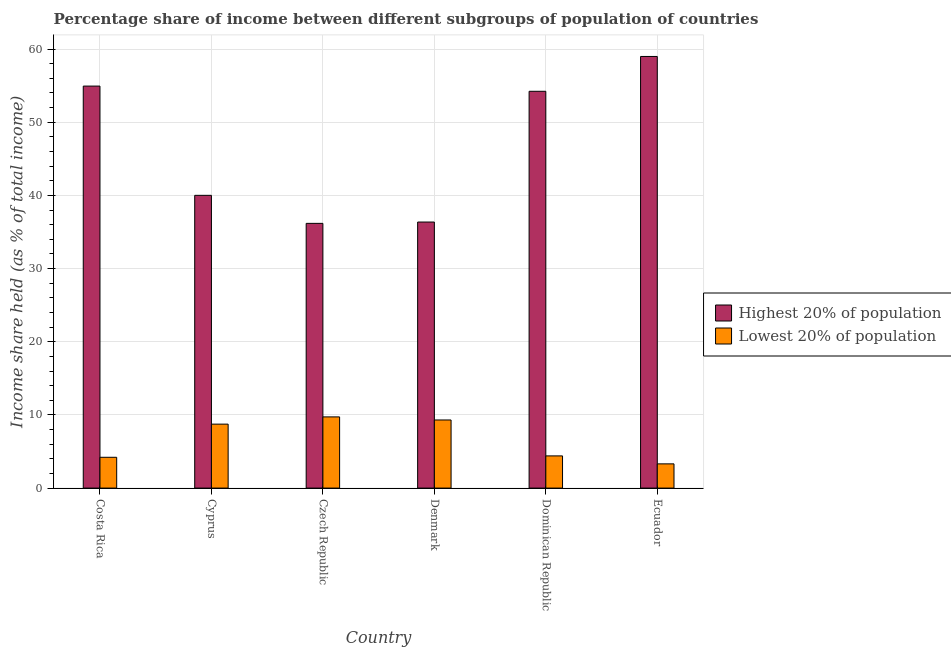How many different coloured bars are there?
Offer a very short reply. 2. How many groups of bars are there?
Your answer should be very brief. 6. Are the number of bars per tick equal to the number of legend labels?
Make the answer very short. Yes. How many bars are there on the 6th tick from the right?
Provide a succinct answer. 2. What is the income share held by highest 20% of the population in Denmark?
Your answer should be very brief. 36.36. Across all countries, what is the maximum income share held by highest 20% of the population?
Your answer should be compact. 58.99. Across all countries, what is the minimum income share held by lowest 20% of the population?
Provide a short and direct response. 3.31. In which country was the income share held by lowest 20% of the population maximum?
Your response must be concise. Czech Republic. In which country was the income share held by highest 20% of the population minimum?
Ensure brevity in your answer.  Czech Republic. What is the total income share held by highest 20% of the population in the graph?
Keep it short and to the point. 280.71. What is the difference between the income share held by lowest 20% of the population in Costa Rica and that in Czech Republic?
Make the answer very short. -5.52. What is the difference between the income share held by highest 20% of the population in Costa Rica and the income share held by lowest 20% of the population in Czech Republic?
Your response must be concise. 45.21. What is the average income share held by lowest 20% of the population per country?
Provide a succinct answer. 6.62. What is the difference between the income share held by highest 20% of the population and income share held by lowest 20% of the population in Costa Rica?
Make the answer very short. 50.73. What is the ratio of the income share held by lowest 20% of the population in Czech Republic to that in Ecuador?
Your response must be concise. 2.94. Is the difference between the income share held by lowest 20% of the population in Costa Rica and Ecuador greater than the difference between the income share held by highest 20% of the population in Costa Rica and Ecuador?
Make the answer very short. Yes. What is the difference between the highest and the second highest income share held by lowest 20% of the population?
Your response must be concise. 0.42. What is the difference between the highest and the lowest income share held by highest 20% of the population?
Make the answer very short. 22.81. In how many countries, is the income share held by lowest 20% of the population greater than the average income share held by lowest 20% of the population taken over all countries?
Provide a short and direct response. 3. Is the sum of the income share held by highest 20% of the population in Costa Rica and Denmark greater than the maximum income share held by lowest 20% of the population across all countries?
Provide a succinct answer. Yes. What does the 2nd bar from the left in Costa Rica represents?
Make the answer very short. Lowest 20% of population. What does the 1st bar from the right in Costa Rica represents?
Ensure brevity in your answer.  Lowest 20% of population. How many bars are there?
Your answer should be compact. 12. Are all the bars in the graph horizontal?
Offer a terse response. No. How many countries are there in the graph?
Provide a short and direct response. 6. What is the difference between two consecutive major ticks on the Y-axis?
Offer a terse response. 10. Does the graph contain grids?
Provide a succinct answer. Yes. What is the title of the graph?
Your answer should be compact. Percentage share of income between different subgroups of population of countries. What is the label or title of the X-axis?
Offer a terse response. Country. What is the label or title of the Y-axis?
Your answer should be very brief. Income share held (as % of total income). What is the Income share held (as % of total income) in Highest 20% of population in Costa Rica?
Ensure brevity in your answer.  54.94. What is the Income share held (as % of total income) of Lowest 20% of population in Costa Rica?
Your answer should be compact. 4.21. What is the Income share held (as % of total income) of Highest 20% of population in Cyprus?
Keep it short and to the point. 40.01. What is the Income share held (as % of total income) in Lowest 20% of population in Cyprus?
Your answer should be compact. 8.74. What is the Income share held (as % of total income) of Highest 20% of population in Czech Republic?
Offer a terse response. 36.18. What is the Income share held (as % of total income) in Lowest 20% of population in Czech Republic?
Provide a succinct answer. 9.73. What is the Income share held (as % of total income) of Highest 20% of population in Denmark?
Offer a very short reply. 36.36. What is the Income share held (as % of total income) in Lowest 20% of population in Denmark?
Your answer should be very brief. 9.31. What is the Income share held (as % of total income) in Highest 20% of population in Dominican Republic?
Offer a terse response. 54.23. What is the Income share held (as % of total income) in Highest 20% of population in Ecuador?
Ensure brevity in your answer.  58.99. What is the Income share held (as % of total income) of Lowest 20% of population in Ecuador?
Your response must be concise. 3.31. Across all countries, what is the maximum Income share held (as % of total income) in Highest 20% of population?
Your answer should be compact. 58.99. Across all countries, what is the maximum Income share held (as % of total income) of Lowest 20% of population?
Your response must be concise. 9.73. Across all countries, what is the minimum Income share held (as % of total income) of Highest 20% of population?
Give a very brief answer. 36.18. Across all countries, what is the minimum Income share held (as % of total income) in Lowest 20% of population?
Offer a very short reply. 3.31. What is the total Income share held (as % of total income) in Highest 20% of population in the graph?
Provide a short and direct response. 280.71. What is the total Income share held (as % of total income) of Lowest 20% of population in the graph?
Your answer should be very brief. 39.7. What is the difference between the Income share held (as % of total income) in Highest 20% of population in Costa Rica and that in Cyprus?
Offer a very short reply. 14.93. What is the difference between the Income share held (as % of total income) in Lowest 20% of population in Costa Rica and that in Cyprus?
Ensure brevity in your answer.  -4.53. What is the difference between the Income share held (as % of total income) in Highest 20% of population in Costa Rica and that in Czech Republic?
Offer a terse response. 18.76. What is the difference between the Income share held (as % of total income) in Lowest 20% of population in Costa Rica and that in Czech Republic?
Provide a succinct answer. -5.52. What is the difference between the Income share held (as % of total income) in Highest 20% of population in Costa Rica and that in Denmark?
Provide a short and direct response. 18.58. What is the difference between the Income share held (as % of total income) of Lowest 20% of population in Costa Rica and that in Denmark?
Provide a succinct answer. -5.1. What is the difference between the Income share held (as % of total income) in Highest 20% of population in Costa Rica and that in Dominican Republic?
Your answer should be compact. 0.71. What is the difference between the Income share held (as % of total income) of Lowest 20% of population in Costa Rica and that in Dominican Republic?
Ensure brevity in your answer.  -0.19. What is the difference between the Income share held (as % of total income) of Highest 20% of population in Costa Rica and that in Ecuador?
Ensure brevity in your answer.  -4.05. What is the difference between the Income share held (as % of total income) in Lowest 20% of population in Costa Rica and that in Ecuador?
Your response must be concise. 0.9. What is the difference between the Income share held (as % of total income) of Highest 20% of population in Cyprus and that in Czech Republic?
Make the answer very short. 3.83. What is the difference between the Income share held (as % of total income) of Lowest 20% of population in Cyprus and that in Czech Republic?
Your answer should be very brief. -0.99. What is the difference between the Income share held (as % of total income) in Highest 20% of population in Cyprus and that in Denmark?
Your answer should be very brief. 3.65. What is the difference between the Income share held (as % of total income) in Lowest 20% of population in Cyprus and that in Denmark?
Give a very brief answer. -0.57. What is the difference between the Income share held (as % of total income) in Highest 20% of population in Cyprus and that in Dominican Republic?
Give a very brief answer. -14.22. What is the difference between the Income share held (as % of total income) in Lowest 20% of population in Cyprus and that in Dominican Republic?
Offer a terse response. 4.34. What is the difference between the Income share held (as % of total income) in Highest 20% of population in Cyprus and that in Ecuador?
Offer a terse response. -18.98. What is the difference between the Income share held (as % of total income) of Lowest 20% of population in Cyprus and that in Ecuador?
Ensure brevity in your answer.  5.43. What is the difference between the Income share held (as % of total income) of Highest 20% of population in Czech Republic and that in Denmark?
Offer a terse response. -0.18. What is the difference between the Income share held (as % of total income) in Lowest 20% of population in Czech Republic and that in Denmark?
Give a very brief answer. 0.42. What is the difference between the Income share held (as % of total income) of Highest 20% of population in Czech Republic and that in Dominican Republic?
Offer a terse response. -18.05. What is the difference between the Income share held (as % of total income) of Lowest 20% of population in Czech Republic and that in Dominican Republic?
Provide a short and direct response. 5.33. What is the difference between the Income share held (as % of total income) in Highest 20% of population in Czech Republic and that in Ecuador?
Make the answer very short. -22.81. What is the difference between the Income share held (as % of total income) in Lowest 20% of population in Czech Republic and that in Ecuador?
Your answer should be compact. 6.42. What is the difference between the Income share held (as % of total income) in Highest 20% of population in Denmark and that in Dominican Republic?
Your answer should be compact. -17.87. What is the difference between the Income share held (as % of total income) of Lowest 20% of population in Denmark and that in Dominican Republic?
Your answer should be compact. 4.91. What is the difference between the Income share held (as % of total income) of Highest 20% of population in Denmark and that in Ecuador?
Provide a succinct answer. -22.63. What is the difference between the Income share held (as % of total income) in Lowest 20% of population in Denmark and that in Ecuador?
Provide a succinct answer. 6. What is the difference between the Income share held (as % of total income) of Highest 20% of population in Dominican Republic and that in Ecuador?
Your answer should be compact. -4.76. What is the difference between the Income share held (as % of total income) in Lowest 20% of population in Dominican Republic and that in Ecuador?
Your answer should be very brief. 1.09. What is the difference between the Income share held (as % of total income) of Highest 20% of population in Costa Rica and the Income share held (as % of total income) of Lowest 20% of population in Cyprus?
Ensure brevity in your answer.  46.2. What is the difference between the Income share held (as % of total income) of Highest 20% of population in Costa Rica and the Income share held (as % of total income) of Lowest 20% of population in Czech Republic?
Your answer should be very brief. 45.21. What is the difference between the Income share held (as % of total income) in Highest 20% of population in Costa Rica and the Income share held (as % of total income) in Lowest 20% of population in Denmark?
Offer a very short reply. 45.63. What is the difference between the Income share held (as % of total income) of Highest 20% of population in Costa Rica and the Income share held (as % of total income) of Lowest 20% of population in Dominican Republic?
Provide a succinct answer. 50.54. What is the difference between the Income share held (as % of total income) in Highest 20% of population in Costa Rica and the Income share held (as % of total income) in Lowest 20% of population in Ecuador?
Make the answer very short. 51.63. What is the difference between the Income share held (as % of total income) of Highest 20% of population in Cyprus and the Income share held (as % of total income) of Lowest 20% of population in Czech Republic?
Make the answer very short. 30.28. What is the difference between the Income share held (as % of total income) of Highest 20% of population in Cyprus and the Income share held (as % of total income) of Lowest 20% of population in Denmark?
Give a very brief answer. 30.7. What is the difference between the Income share held (as % of total income) of Highest 20% of population in Cyprus and the Income share held (as % of total income) of Lowest 20% of population in Dominican Republic?
Ensure brevity in your answer.  35.61. What is the difference between the Income share held (as % of total income) in Highest 20% of population in Cyprus and the Income share held (as % of total income) in Lowest 20% of population in Ecuador?
Provide a short and direct response. 36.7. What is the difference between the Income share held (as % of total income) in Highest 20% of population in Czech Republic and the Income share held (as % of total income) in Lowest 20% of population in Denmark?
Offer a very short reply. 26.87. What is the difference between the Income share held (as % of total income) in Highest 20% of population in Czech Republic and the Income share held (as % of total income) in Lowest 20% of population in Dominican Republic?
Your answer should be very brief. 31.78. What is the difference between the Income share held (as % of total income) in Highest 20% of population in Czech Republic and the Income share held (as % of total income) in Lowest 20% of population in Ecuador?
Ensure brevity in your answer.  32.87. What is the difference between the Income share held (as % of total income) in Highest 20% of population in Denmark and the Income share held (as % of total income) in Lowest 20% of population in Dominican Republic?
Give a very brief answer. 31.96. What is the difference between the Income share held (as % of total income) in Highest 20% of population in Denmark and the Income share held (as % of total income) in Lowest 20% of population in Ecuador?
Offer a terse response. 33.05. What is the difference between the Income share held (as % of total income) in Highest 20% of population in Dominican Republic and the Income share held (as % of total income) in Lowest 20% of population in Ecuador?
Your answer should be compact. 50.92. What is the average Income share held (as % of total income) in Highest 20% of population per country?
Give a very brief answer. 46.78. What is the average Income share held (as % of total income) of Lowest 20% of population per country?
Ensure brevity in your answer.  6.62. What is the difference between the Income share held (as % of total income) in Highest 20% of population and Income share held (as % of total income) in Lowest 20% of population in Costa Rica?
Your response must be concise. 50.73. What is the difference between the Income share held (as % of total income) of Highest 20% of population and Income share held (as % of total income) of Lowest 20% of population in Cyprus?
Keep it short and to the point. 31.27. What is the difference between the Income share held (as % of total income) of Highest 20% of population and Income share held (as % of total income) of Lowest 20% of population in Czech Republic?
Your response must be concise. 26.45. What is the difference between the Income share held (as % of total income) in Highest 20% of population and Income share held (as % of total income) in Lowest 20% of population in Denmark?
Offer a terse response. 27.05. What is the difference between the Income share held (as % of total income) of Highest 20% of population and Income share held (as % of total income) of Lowest 20% of population in Dominican Republic?
Your answer should be compact. 49.83. What is the difference between the Income share held (as % of total income) of Highest 20% of population and Income share held (as % of total income) of Lowest 20% of population in Ecuador?
Your answer should be very brief. 55.68. What is the ratio of the Income share held (as % of total income) in Highest 20% of population in Costa Rica to that in Cyprus?
Make the answer very short. 1.37. What is the ratio of the Income share held (as % of total income) of Lowest 20% of population in Costa Rica to that in Cyprus?
Your response must be concise. 0.48. What is the ratio of the Income share held (as % of total income) of Highest 20% of population in Costa Rica to that in Czech Republic?
Your answer should be compact. 1.52. What is the ratio of the Income share held (as % of total income) of Lowest 20% of population in Costa Rica to that in Czech Republic?
Your response must be concise. 0.43. What is the ratio of the Income share held (as % of total income) of Highest 20% of population in Costa Rica to that in Denmark?
Your answer should be compact. 1.51. What is the ratio of the Income share held (as % of total income) of Lowest 20% of population in Costa Rica to that in Denmark?
Your response must be concise. 0.45. What is the ratio of the Income share held (as % of total income) in Highest 20% of population in Costa Rica to that in Dominican Republic?
Your response must be concise. 1.01. What is the ratio of the Income share held (as % of total income) of Lowest 20% of population in Costa Rica to that in Dominican Republic?
Offer a very short reply. 0.96. What is the ratio of the Income share held (as % of total income) of Highest 20% of population in Costa Rica to that in Ecuador?
Offer a very short reply. 0.93. What is the ratio of the Income share held (as % of total income) of Lowest 20% of population in Costa Rica to that in Ecuador?
Your answer should be compact. 1.27. What is the ratio of the Income share held (as % of total income) of Highest 20% of population in Cyprus to that in Czech Republic?
Provide a short and direct response. 1.11. What is the ratio of the Income share held (as % of total income) of Lowest 20% of population in Cyprus to that in Czech Republic?
Your response must be concise. 0.9. What is the ratio of the Income share held (as % of total income) of Highest 20% of population in Cyprus to that in Denmark?
Your response must be concise. 1.1. What is the ratio of the Income share held (as % of total income) in Lowest 20% of population in Cyprus to that in Denmark?
Offer a terse response. 0.94. What is the ratio of the Income share held (as % of total income) in Highest 20% of population in Cyprus to that in Dominican Republic?
Provide a succinct answer. 0.74. What is the ratio of the Income share held (as % of total income) in Lowest 20% of population in Cyprus to that in Dominican Republic?
Provide a succinct answer. 1.99. What is the ratio of the Income share held (as % of total income) in Highest 20% of population in Cyprus to that in Ecuador?
Your answer should be compact. 0.68. What is the ratio of the Income share held (as % of total income) in Lowest 20% of population in Cyprus to that in Ecuador?
Your answer should be very brief. 2.64. What is the ratio of the Income share held (as % of total income) in Lowest 20% of population in Czech Republic to that in Denmark?
Keep it short and to the point. 1.05. What is the ratio of the Income share held (as % of total income) in Highest 20% of population in Czech Republic to that in Dominican Republic?
Ensure brevity in your answer.  0.67. What is the ratio of the Income share held (as % of total income) in Lowest 20% of population in Czech Republic to that in Dominican Republic?
Keep it short and to the point. 2.21. What is the ratio of the Income share held (as % of total income) of Highest 20% of population in Czech Republic to that in Ecuador?
Your response must be concise. 0.61. What is the ratio of the Income share held (as % of total income) in Lowest 20% of population in Czech Republic to that in Ecuador?
Your response must be concise. 2.94. What is the ratio of the Income share held (as % of total income) of Highest 20% of population in Denmark to that in Dominican Republic?
Your answer should be very brief. 0.67. What is the ratio of the Income share held (as % of total income) in Lowest 20% of population in Denmark to that in Dominican Republic?
Provide a succinct answer. 2.12. What is the ratio of the Income share held (as % of total income) of Highest 20% of population in Denmark to that in Ecuador?
Your answer should be very brief. 0.62. What is the ratio of the Income share held (as % of total income) in Lowest 20% of population in Denmark to that in Ecuador?
Your answer should be compact. 2.81. What is the ratio of the Income share held (as % of total income) in Highest 20% of population in Dominican Republic to that in Ecuador?
Offer a terse response. 0.92. What is the ratio of the Income share held (as % of total income) of Lowest 20% of population in Dominican Republic to that in Ecuador?
Your response must be concise. 1.33. What is the difference between the highest and the second highest Income share held (as % of total income) of Highest 20% of population?
Keep it short and to the point. 4.05. What is the difference between the highest and the second highest Income share held (as % of total income) in Lowest 20% of population?
Provide a short and direct response. 0.42. What is the difference between the highest and the lowest Income share held (as % of total income) of Highest 20% of population?
Offer a terse response. 22.81. What is the difference between the highest and the lowest Income share held (as % of total income) of Lowest 20% of population?
Your answer should be very brief. 6.42. 